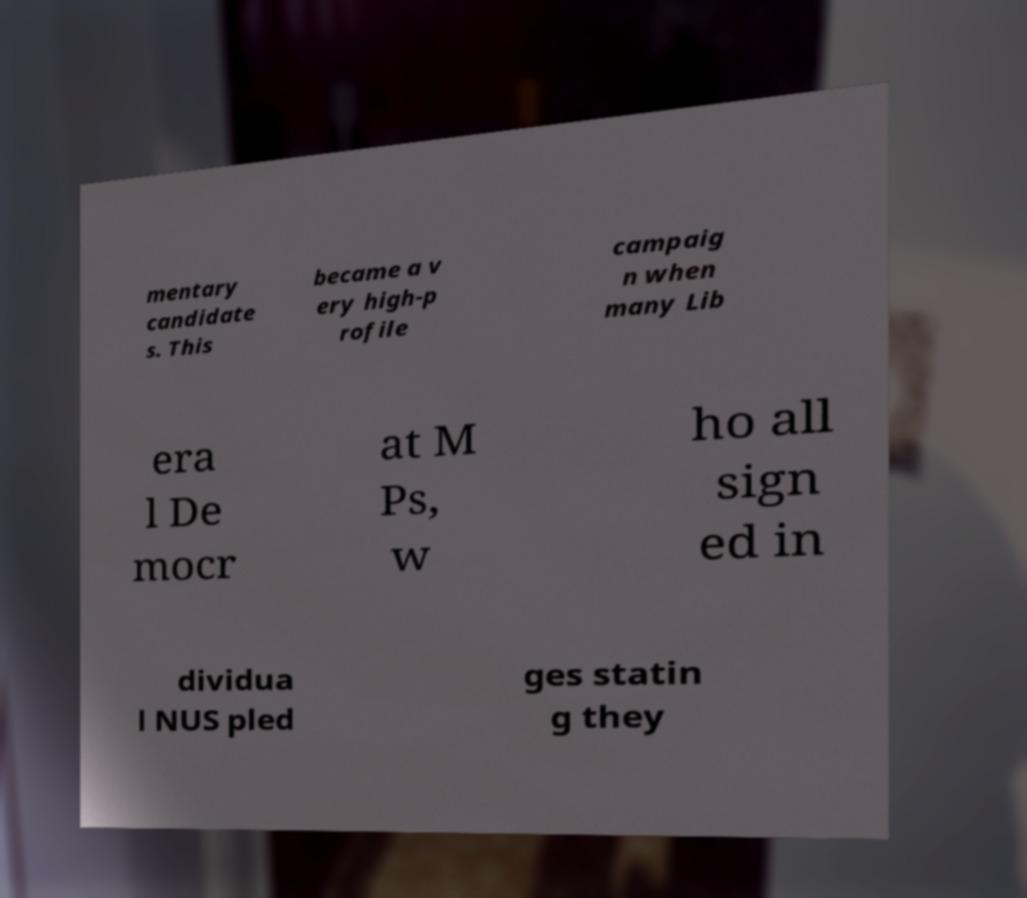Could you extract and type out the text from this image? mentary candidate s. This became a v ery high-p rofile campaig n when many Lib era l De mocr at M Ps, w ho all sign ed in dividua l NUS pled ges statin g they 